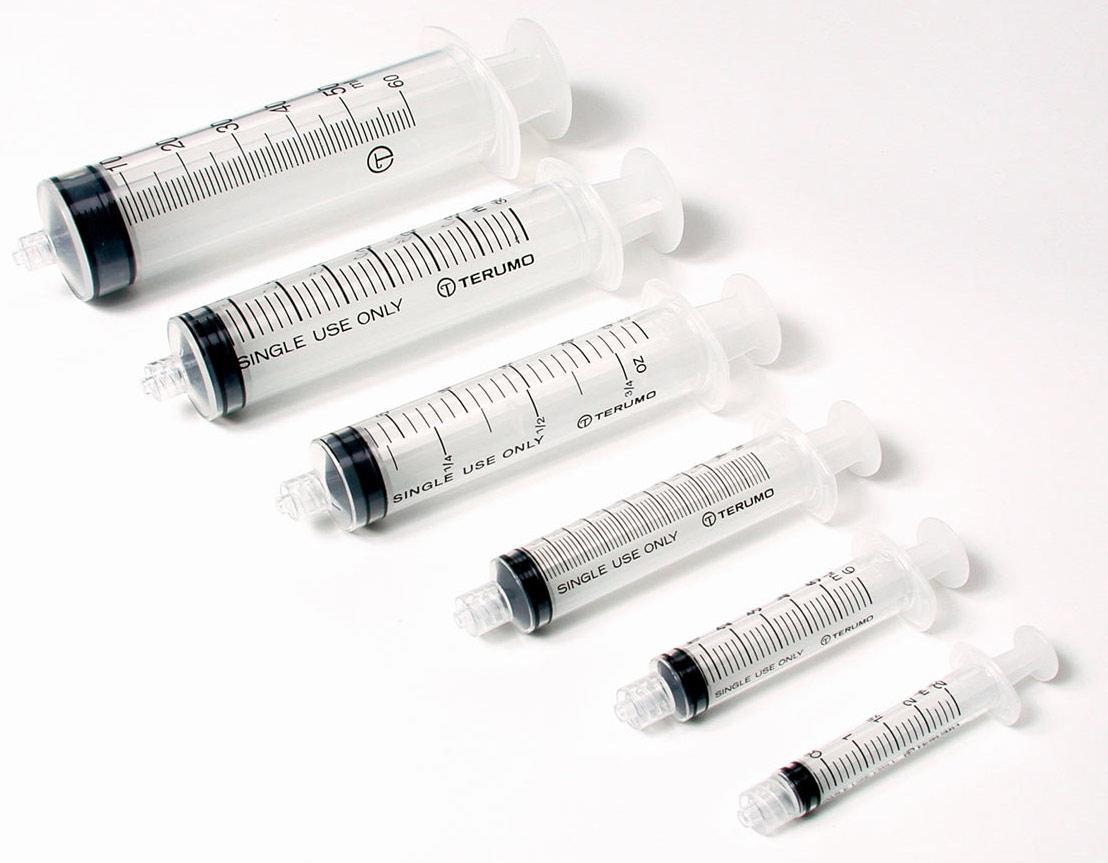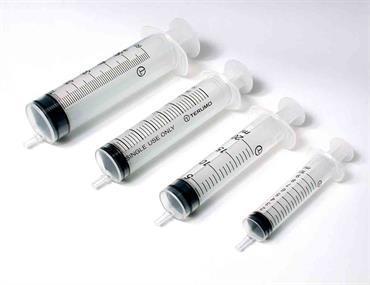The first image is the image on the left, the second image is the image on the right. Examine the images to the left and right. Is the description "At least one packaged syringe is in front of a box, in one image." accurate? Answer yes or no. No. The first image is the image on the left, the second image is the image on the right. For the images displayed, is the sentence "The left image has at least one syringe laying down in front of a box." factually correct? Answer yes or no. No. 